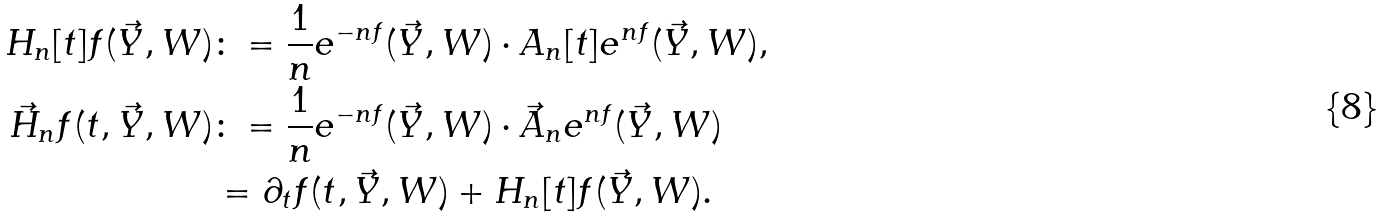Convert formula to latex. <formula><loc_0><loc_0><loc_500><loc_500>H _ { n } [ t ] f ( \vec { Y } , W ) & \colon = \frac { 1 } { n } e ^ { - n f } ( \vec { Y } , W ) \cdot A _ { n } [ t ] e ^ { n f } ( \vec { Y } , W ) , \\ \vec { H } _ { n } f ( t , \vec { Y } , W ) & \colon = \frac { 1 } { n } e ^ { - n f } ( \vec { Y } , W ) \cdot \vec { A } _ { n } e ^ { n f } ( \vec { Y } , W ) \\ & = \partial _ { t } f ( t , \vec { Y } , W ) + H _ { n } [ t ] f ( \vec { Y } , W ) .</formula> 